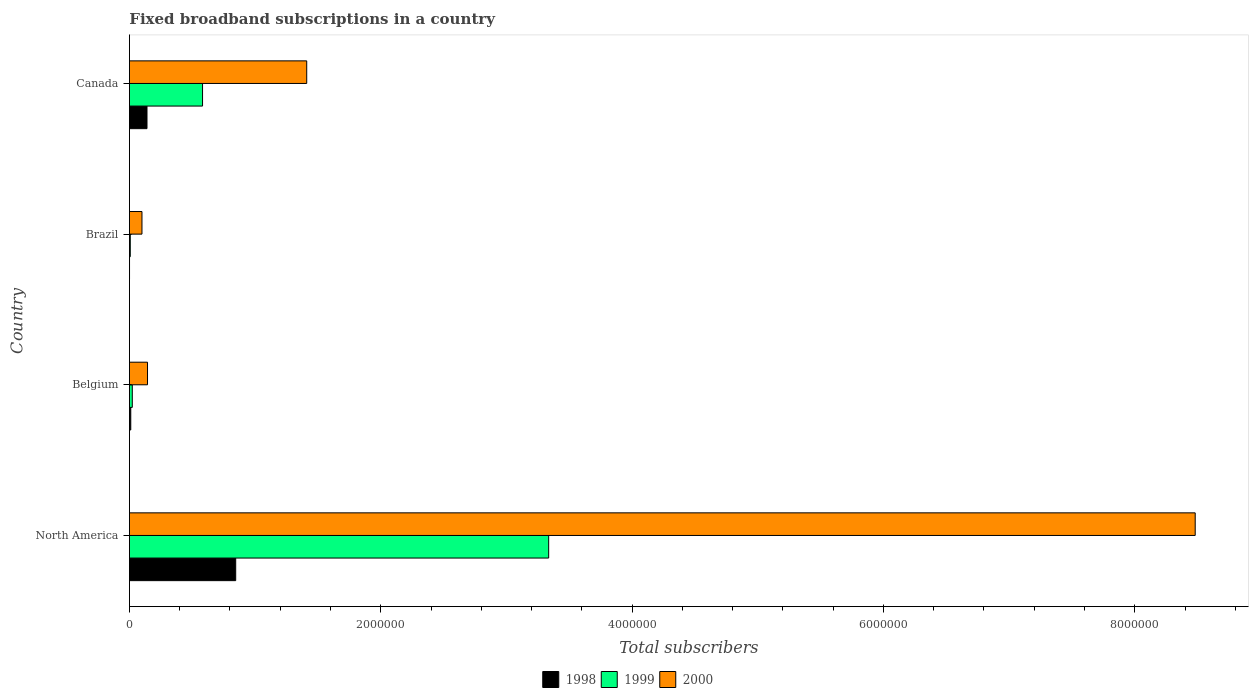How many different coloured bars are there?
Offer a very short reply. 3. How many groups of bars are there?
Your answer should be compact. 4. Are the number of bars per tick equal to the number of legend labels?
Make the answer very short. Yes. How many bars are there on the 4th tick from the top?
Offer a very short reply. 3. How many bars are there on the 2nd tick from the bottom?
Provide a succinct answer. 3. In how many cases, is the number of bars for a given country not equal to the number of legend labels?
Offer a very short reply. 0. What is the number of broadband subscriptions in 1999 in North America?
Offer a very short reply. 3.34e+06. Across all countries, what is the maximum number of broadband subscriptions in 1999?
Make the answer very short. 3.34e+06. In which country was the number of broadband subscriptions in 2000 minimum?
Offer a terse response. Brazil. What is the total number of broadband subscriptions in 1998 in the graph?
Your response must be concise. 9.98e+05. What is the difference between the number of broadband subscriptions in 1998 in Brazil and that in North America?
Give a very brief answer. -8.45e+05. What is the difference between the number of broadband subscriptions in 1999 in Canada and the number of broadband subscriptions in 1998 in Belgium?
Offer a terse response. 5.71e+05. What is the average number of broadband subscriptions in 2000 per country?
Offer a terse response. 2.53e+06. What is the difference between the number of broadband subscriptions in 1999 and number of broadband subscriptions in 2000 in Brazil?
Offer a very short reply. -9.30e+04. In how many countries, is the number of broadband subscriptions in 1998 greater than 6400000 ?
Your answer should be compact. 0. What is the ratio of the number of broadband subscriptions in 1999 in Belgium to that in Canada?
Your answer should be very brief. 0.04. Is the difference between the number of broadband subscriptions in 1999 in Brazil and North America greater than the difference between the number of broadband subscriptions in 2000 in Brazil and North America?
Keep it short and to the point. Yes. What is the difference between the highest and the second highest number of broadband subscriptions in 1999?
Keep it short and to the point. 2.75e+06. What is the difference between the highest and the lowest number of broadband subscriptions in 1998?
Keep it short and to the point. 8.45e+05. In how many countries, is the number of broadband subscriptions in 1999 greater than the average number of broadband subscriptions in 1999 taken over all countries?
Provide a short and direct response. 1. What does the 3rd bar from the top in Belgium represents?
Your answer should be very brief. 1998. What does the 1st bar from the bottom in Belgium represents?
Your answer should be compact. 1998. How many bars are there?
Give a very brief answer. 12. How many countries are there in the graph?
Your response must be concise. 4. Are the values on the major ticks of X-axis written in scientific E-notation?
Make the answer very short. No. Does the graph contain grids?
Provide a short and direct response. No. What is the title of the graph?
Your response must be concise. Fixed broadband subscriptions in a country. What is the label or title of the X-axis?
Offer a terse response. Total subscribers. What is the Total subscribers of 1998 in North America?
Provide a short and direct response. 8.46e+05. What is the Total subscribers in 1999 in North America?
Keep it short and to the point. 3.34e+06. What is the Total subscribers in 2000 in North America?
Your answer should be compact. 8.48e+06. What is the Total subscribers in 1998 in Belgium?
Offer a very short reply. 1.09e+04. What is the Total subscribers of 1999 in Belgium?
Your answer should be very brief. 2.30e+04. What is the Total subscribers of 2000 in Belgium?
Provide a succinct answer. 1.44e+05. What is the Total subscribers in 1999 in Brazil?
Your answer should be very brief. 7000. What is the Total subscribers of 2000 in Brazil?
Your answer should be very brief. 1.00e+05. What is the Total subscribers in 1999 in Canada?
Your answer should be compact. 5.82e+05. What is the Total subscribers in 2000 in Canada?
Make the answer very short. 1.41e+06. Across all countries, what is the maximum Total subscribers in 1998?
Give a very brief answer. 8.46e+05. Across all countries, what is the maximum Total subscribers in 1999?
Provide a succinct answer. 3.34e+06. Across all countries, what is the maximum Total subscribers of 2000?
Ensure brevity in your answer.  8.48e+06. Across all countries, what is the minimum Total subscribers of 1999?
Your answer should be compact. 7000. Across all countries, what is the minimum Total subscribers of 2000?
Ensure brevity in your answer.  1.00e+05. What is the total Total subscribers of 1998 in the graph?
Offer a very short reply. 9.98e+05. What is the total Total subscribers in 1999 in the graph?
Provide a succinct answer. 3.95e+06. What is the total Total subscribers in 2000 in the graph?
Make the answer very short. 1.01e+07. What is the difference between the Total subscribers in 1998 in North America and that in Belgium?
Your response must be concise. 8.35e+05. What is the difference between the Total subscribers in 1999 in North America and that in Belgium?
Ensure brevity in your answer.  3.31e+06. What is the difference between the Total subscribers in 2000 in North America and that in Belgium?
Your response must be concise. 8.34e+06. What is the difference between the Total subscribers of 1998 in North America and that in Brazil?
Offer a very short reply. 8.45e+05. What is the difference between the Total subscribers of 1999 in North America and that in Brazil?
Give a very brief answer. 3.33e+06. What is the difference between the Total subscribers in 2000 in North America and that in Brazil?
Make the answer very short. 8.38e+06. What is the difference between the Total subscribers in 1998 in North America and that in Canada?
Your response must be concise. 7.06e+05. What is the difference between the Total subscribers of 1999 in North America and that in Canada?
Provide a short and direct response. 2.75e+06. What is the difference between the Total subscribers of 2000 in North America and that in Canada?
Ensure brevity in your answer.  7.07e+06. What is the difference between the Total subscribers in 1998 in Belgium and that in Brazil?
Your answer should be compact. 9924. What is the difference between the Total subscribers of 1999 in Belgium and that in Brazil?
Make the answer very short. 1.60e+04. What is the difference between the Total subscribers in 2000 in Belgium and that in Brazil?
Keep it short and to the point. 4.42e+04. What is the difference between the Total subscribers in 1998 in Belgium and that in Canada?
Provide a short and direct response. -1.29e+05. What is the difference between the Total subscribers of 1999 in Belgium and that in Canada?
Your response must be concise. -5.59e+05. What is the difference between the Total subscribers in 2000 in Belgium and that in Canada?
Your response must be concise. -1.27e+06. What is the difference between the Total subscribers of 1998 in Brazil and that in Canada?
Offer a very short reply. -1.39e+05. What is the difference between the Total subscribers in 1999 in Brazil and that in Canada?
Give a very brief answer. -5.75e+05. What is the difference between the Total subscribers in 2000 in Brazil and that in Canada?
Ensure brevity in your answer.  -1.31e+06. What is the difference between the Total subscribers of 1998 in North America and the Total subscribers of 1999 in Belgium?
Make the answer very short. 8.23e+05. What is the difference between the Total subscribers in 1998 in North America and the Total subscribers in 2000 in Belgium?
Your answer should be compact. 7.02e+05. What is the difference between the Total subscribers in 1999 in North America and the Total subscribers in 2000 in Belgium?
Make the answer very short. 3.19e+06. What is the difference between the Total subscribers of 1998 in North America and the Total subscribers of 1999 in Brazil?
Give a very brief answer. 8.39e+05. What is the difference between the Total subscribers of 1998 in North America and the Total subscribers of 2000 in Brazil?
Give a very brief answer. 7.46e+05. What is the difference between the Total subscribers in 1999 in North America and the Total subscribers in 2000 in Brazil?
Keep it short and to the point. 3.24e+06. What is the difference between the Total subscribers of 1998 in North America and the Total subscribers of 1999 in Canada?
Offer a terse response. 2.64e+05. What is the difference between the Total subscribers in 1998 in North America and the Total subscribers in 2000 in Canada?
Provide a short and direct response. -5.65e+05. What is the difference between the Total subscribers of 1999 in North America and the Total subscribers of 2000 in Canada?
Your answer should be compact. 1.93e+06. What is the difference between the Total subscribers in 1998 in Belgium and the Total subscribers in 1999 in Brazil?
Offer a very short reply. 3924. What is the difference between the Total subscribers of 1998 in Belgium and the Total subscribers of 2000 in Brazil?
Your answer should be compact. -8.91e+04. What is the difference between the Total subscribers in 1999 in Belgium and the Total subscribers in 2000 in Brazil?
Offer a terse response. -7.70e+04. What is the difference between the Total subscribers in 1998 in Belgium and the Total subscribers in 1999 in Canada?
Give a very brief answer. -5.71e+05. What is the difference between the Total subscribers of 1998 in Belgium and the Total subscribers of 2000 in Canada?
Provide a short and direct response. -1.40e+06. What is the difference between the Total subscribers in 1999 in Belgium and the Total subscribers in 2000 in Canada?
Offer a very short reply. -1.39e+06. What is the difference between the Total subscribers of 1998 in Brazil and the Total subscribers of 1999 in Canada?
Keep it short and to the point. -5.81e+05. What is the difference between the Total subscribers of 1998 in Brazil and the Total subscribers of 2000 in Canada?
Provide a succinct answer. -1.41e+06. What is the difference between the Total subscribers in 1999 in Brazil and the Total subscribers in 2000 in Canada?
Keep it short and to the point. -1.40e+06. What is the average Total subscribers of 1998 per country?
Give a very brief answer. 2.49e+05. What is the average Total subscribers of 1999 per country?
Give a very brief answer. 9.87e+05. What is the average Total subscribers of 2000 per country?
Provide a short and direct response. 2.53e+06. What is the difference between the Total subscribers in 1998 and Total subscribers in 1999 in North America?
Your answer should be very brief. -2.49e+06. What is the difference between the Total subscribers of 1998 and Total subscribers of 2000 in North America?
Your answer should be compact. -7.63e+06. What is the difference between the Total subscribers in 1999 and Total subscribers in 2000 in North America?
Keep it short and to the point. -5.14e+06. What is the difference between the Total subscribers of 1998 and Total subscribers of 1999 in Belgium?
Provide a succinct answer. -1.21e+04. What is the difference between the Total subscribers of 1998 and Total subscribers of 2000 in Belgium?
Provide a succinct answer. -1.33e+05. What is the difference between the Total subscribers of 1999 and Total subscribers of 2000 in Belgium?
Your answer should be very brief. -1.21e+05. What is the difference between the Total subscribers in 1998 and Total subscribers in 1999 in Brazil?
Give a very brief answer. -6000. What is the difference between the Total subscribers of 1998 and Total subscribers of 2000 in Brazil?
Give a very brief answer. -9.90e+04. What is the difference between the Total subscribers in 1999 and Total subscribers in 2000 in Brazil?
Offer a terse response. -9.30e+04. What is the difference between the Total subscribers of 1998 and Total subscribers of 1999 in Canada?
Offer a terse response. -4.42e+05. What is the difference between the Total subscribers in 1998 and Total subscribers in 2000 in Canada?
Your answer should be very brief. -1.27e+06. What is the difference between the Total subscribers in 1999 and Total subscribers in 2000 in Canada?
Your response must be concise. -8.29e+05. What is the ratio of the Total subscribers in 1998 in North America to that in Belgium?
Make the answer very short. 77.44. What is the ratio of the Total subscribers of 1999 in North America to that in Belgium?
Your response must be concise. 145.06. What is the ratio of the Total subscribers in 2000 in North America to that in Belgium?
Your answer should be compact. 58.81. What is the ratio of the Total subscribers in 1998 in North America to that in Brazil?
Offer a very short reply. 845.9. What is the ratio of the Total subscribers of 1999 in North America to that in Brazil?
Ensure brevity in your answer.  476.61. What is the ratio of the Total subscribers in 2000 in North America to that in Brazil?
Offer a terse response. 84.81. What is the ratio of the Total subscribers of 1998 in North America to that in Canada?
Give a very brief answer. 6.04. What is the ratio of the Total subscribers in 1999 in North America to that in Canada?
Provide a succinct answer. 5.73. What is the ratio of the Total subscribers of 2000 in North America to that in Canada?
Provide a short and direct response. 6.01. What is the ratio of the Total subscribers of 1998 in Belgium to that in Brazil?
Your response must be concise. 10.92. What is the ratio of the Total subscribers of 1999 in Belgium to that in Brazil?
Offer a very short reply. 3.29. What is the ratio of the Total subscribers in 2000 in Belgium to that in Brazil?
Make the answer very short. 1.44. What is the ratio of the Total subscribers of 1998 in Belgium to that in Canada?
Your answer should be very brief. 0.08. What is the ratio of the Total subscribers of 1999 in Belgium to that in Canada?
Ensure brevity in your answer.  0.04. What is the ratio of the Total subscribers of 2000 in Belgium to that in Canada?
Offer a terse response. 0.1. What is the ratio of the Total subscribers in 1998 in Brazil to that in Canada?
Your response must be concise. 0.01. What is the ratio of the Total subscribers of 1999 in Brazil to that in Canada?
Your answer should be very brief. 0.01. What is the ratio of the Total subscribers in 2000 in Brazil to that in Canada?
Your answer should be compact. 0.07. What is the difference between the highest and the second highest Total subscribers in 1998?
Offer a very short reply. 7.06e+05. What is the difference between the highest and the second highest Total subscribers of 1999?
Ensure brevity in your answer.  2.75e+06. What is the difference between the highest and the second highest Total subscribers in 2000?
Your response must be concise. 7.07e+06. What is the difference between the highest and the lowest Total subscribers of 1998?
Ensure brevity in your answer.  8.45e+05. What is the difference between the highest and the lowest Total subscribers in 1999?
Ensure brevity in your answer.  3.33e+06. What is the difference between the highest and the lowest Total subscribers in 2000?
Make the answer very short. 8.38e+06. 